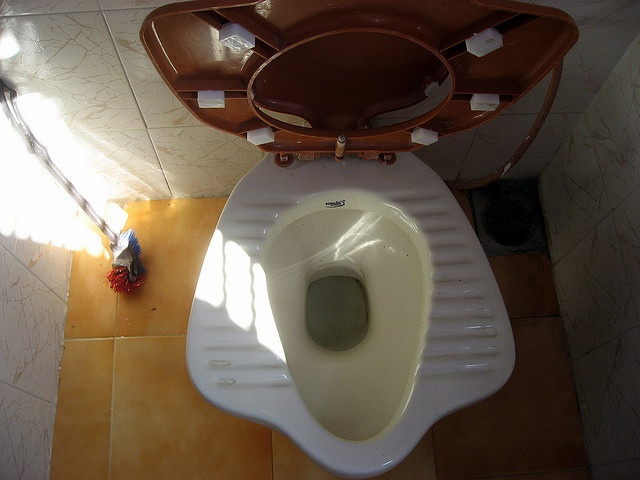Describe the objects in this image and their specific colors. I can see a toilet in gray, black, darkgray, and maroon tones in this image. 